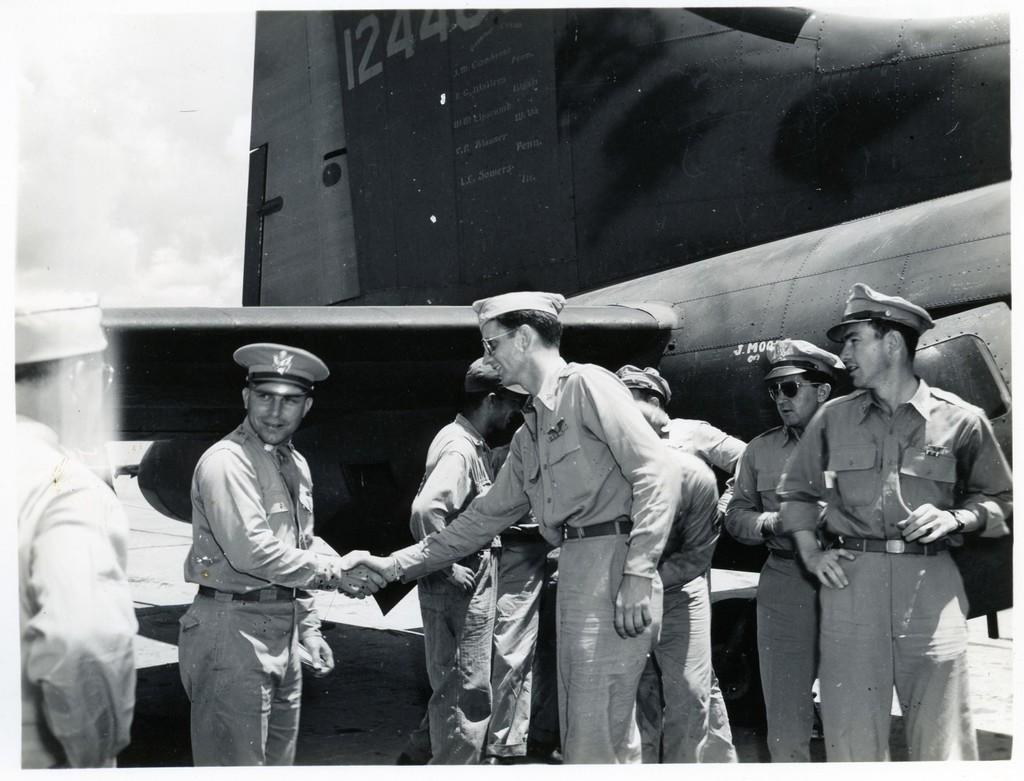What numbers are visible on the plane?
Keep it short and to the point. 1244. 